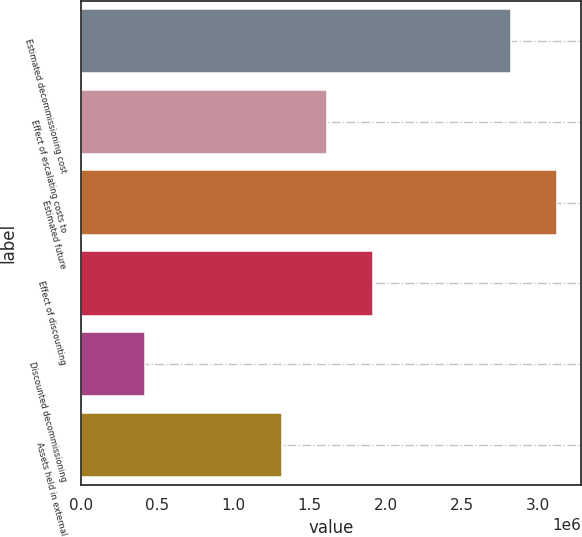<chart> <loc_0><loc_0><loc_500><loc_500><bar_chart><fcel>Estimated decommissioning cost<fcel>Effect of escalating costs to<fcel>Estimated future<fcel>Effect of discounting<fcel>Discounted decommissioning<fcel>Assets held in external<nl><fcel>2.8191e+06<fcel>1.61787e+06<fcel>3.12683e+06<fcel>1.91818e+06<fcel>424068<fcel>1.31756e+06<nl></chart> 